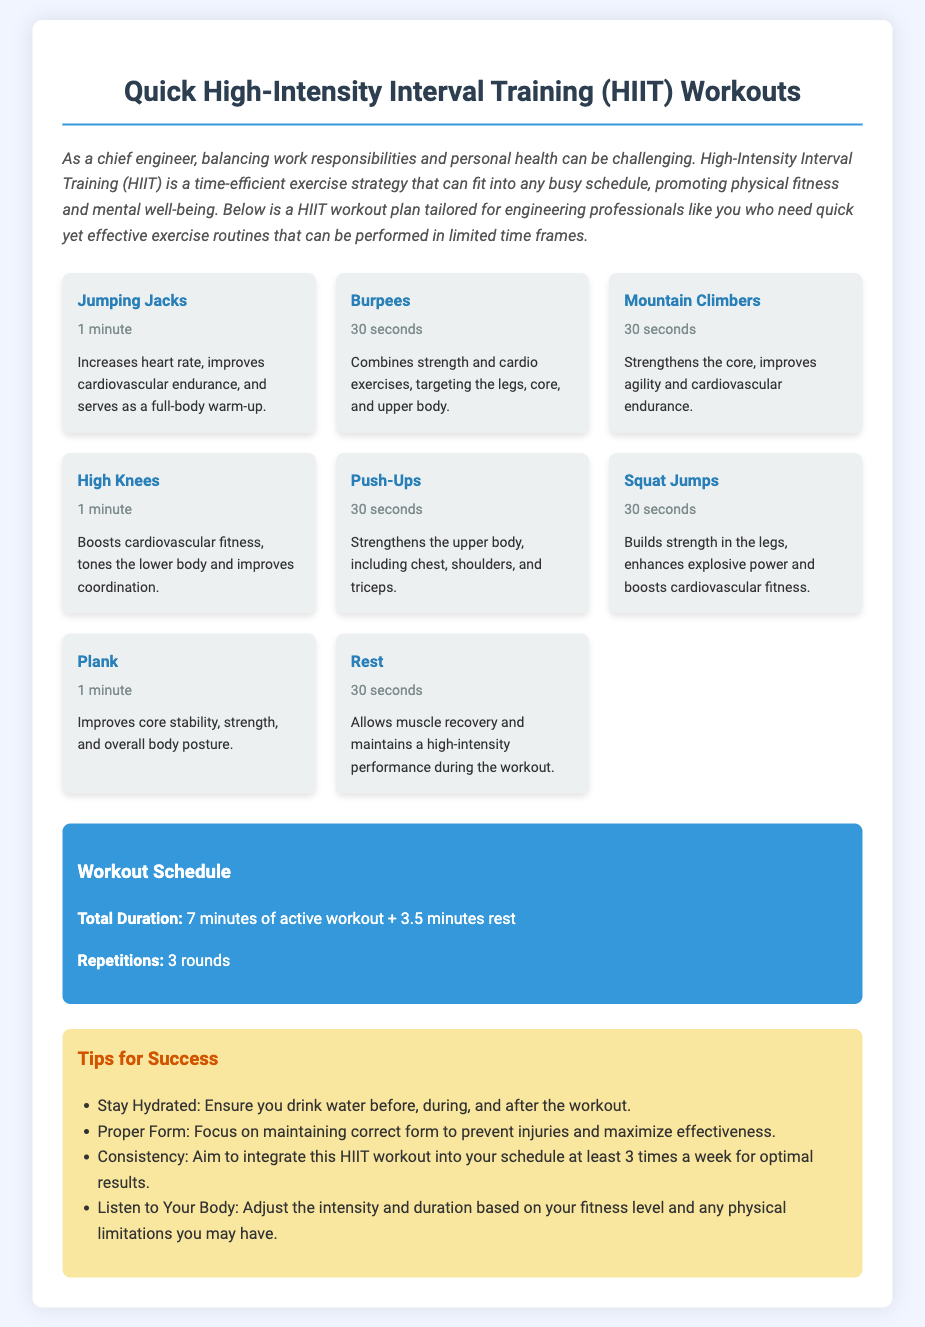what is the duration of the workout schedule? The total duration of the workout schedule is specified in the document as 7 minutes of active workout plus 3.5 minutes of rest.
Answer: 7 minutes how many rounds should the workout be repeated? The document states that the workout should be done for 3 rounds.
Answer: 3 rounds which exercise lasts for 1 minute? The exercises that last for 1 minute are specifically listed in the document. They include Jumping Jacks and Plank.
Answer: Jumping Jacks, Plank what is one benefit of Burpees? The document lists the benefits of Burpees, highlighting that they combine strength and cardio exercises.
Answer: Combines strength and cardio exercises why is it important to stay hydrated during workouts? Staying hydrated is mentioned as essential to ensure optimal workout performance and recovery.
Answer: Ensures optimal performance how many exercises are included in the HIIT workout plan? The document includes a total of 8 exercises in the HIIT workout plan.
Answer: 8 exercises what should you focus on to prevent injuries during workouts? The document advises maintaining correct form to prevent injuries during workouts.
Answer: Proper Form what is one of the tips for success mentioned? The document provides a list of tips for success, one of which is to aim for consistency in the workout schedule.
Answer: Consistency 